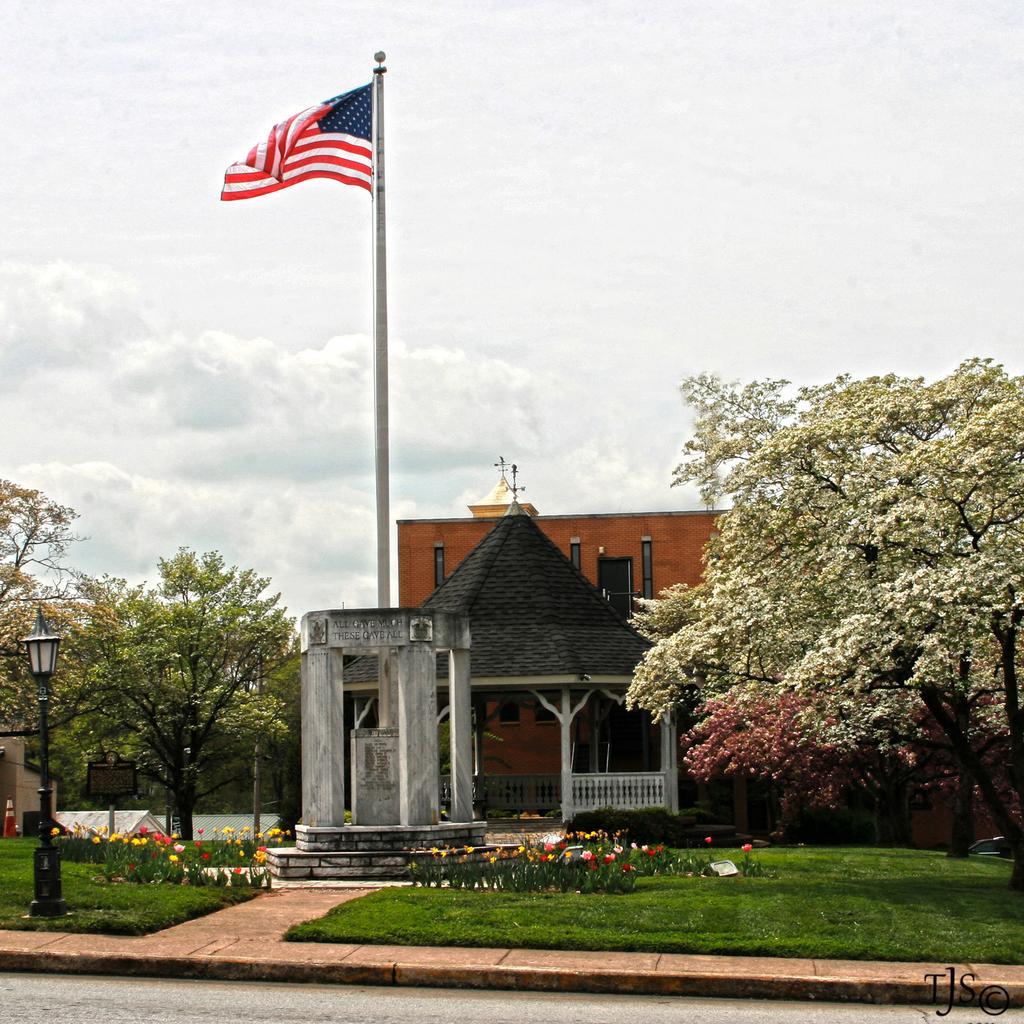Please provide a concise description of this image. In this image we can see a memorial. We can also see the flag, a roof but and also the building. The image also consists of trees, flower plants, light pole and also grows. We can also see the path. In the background there is a cloudy sky and in the bottom right corner we can see the text. 